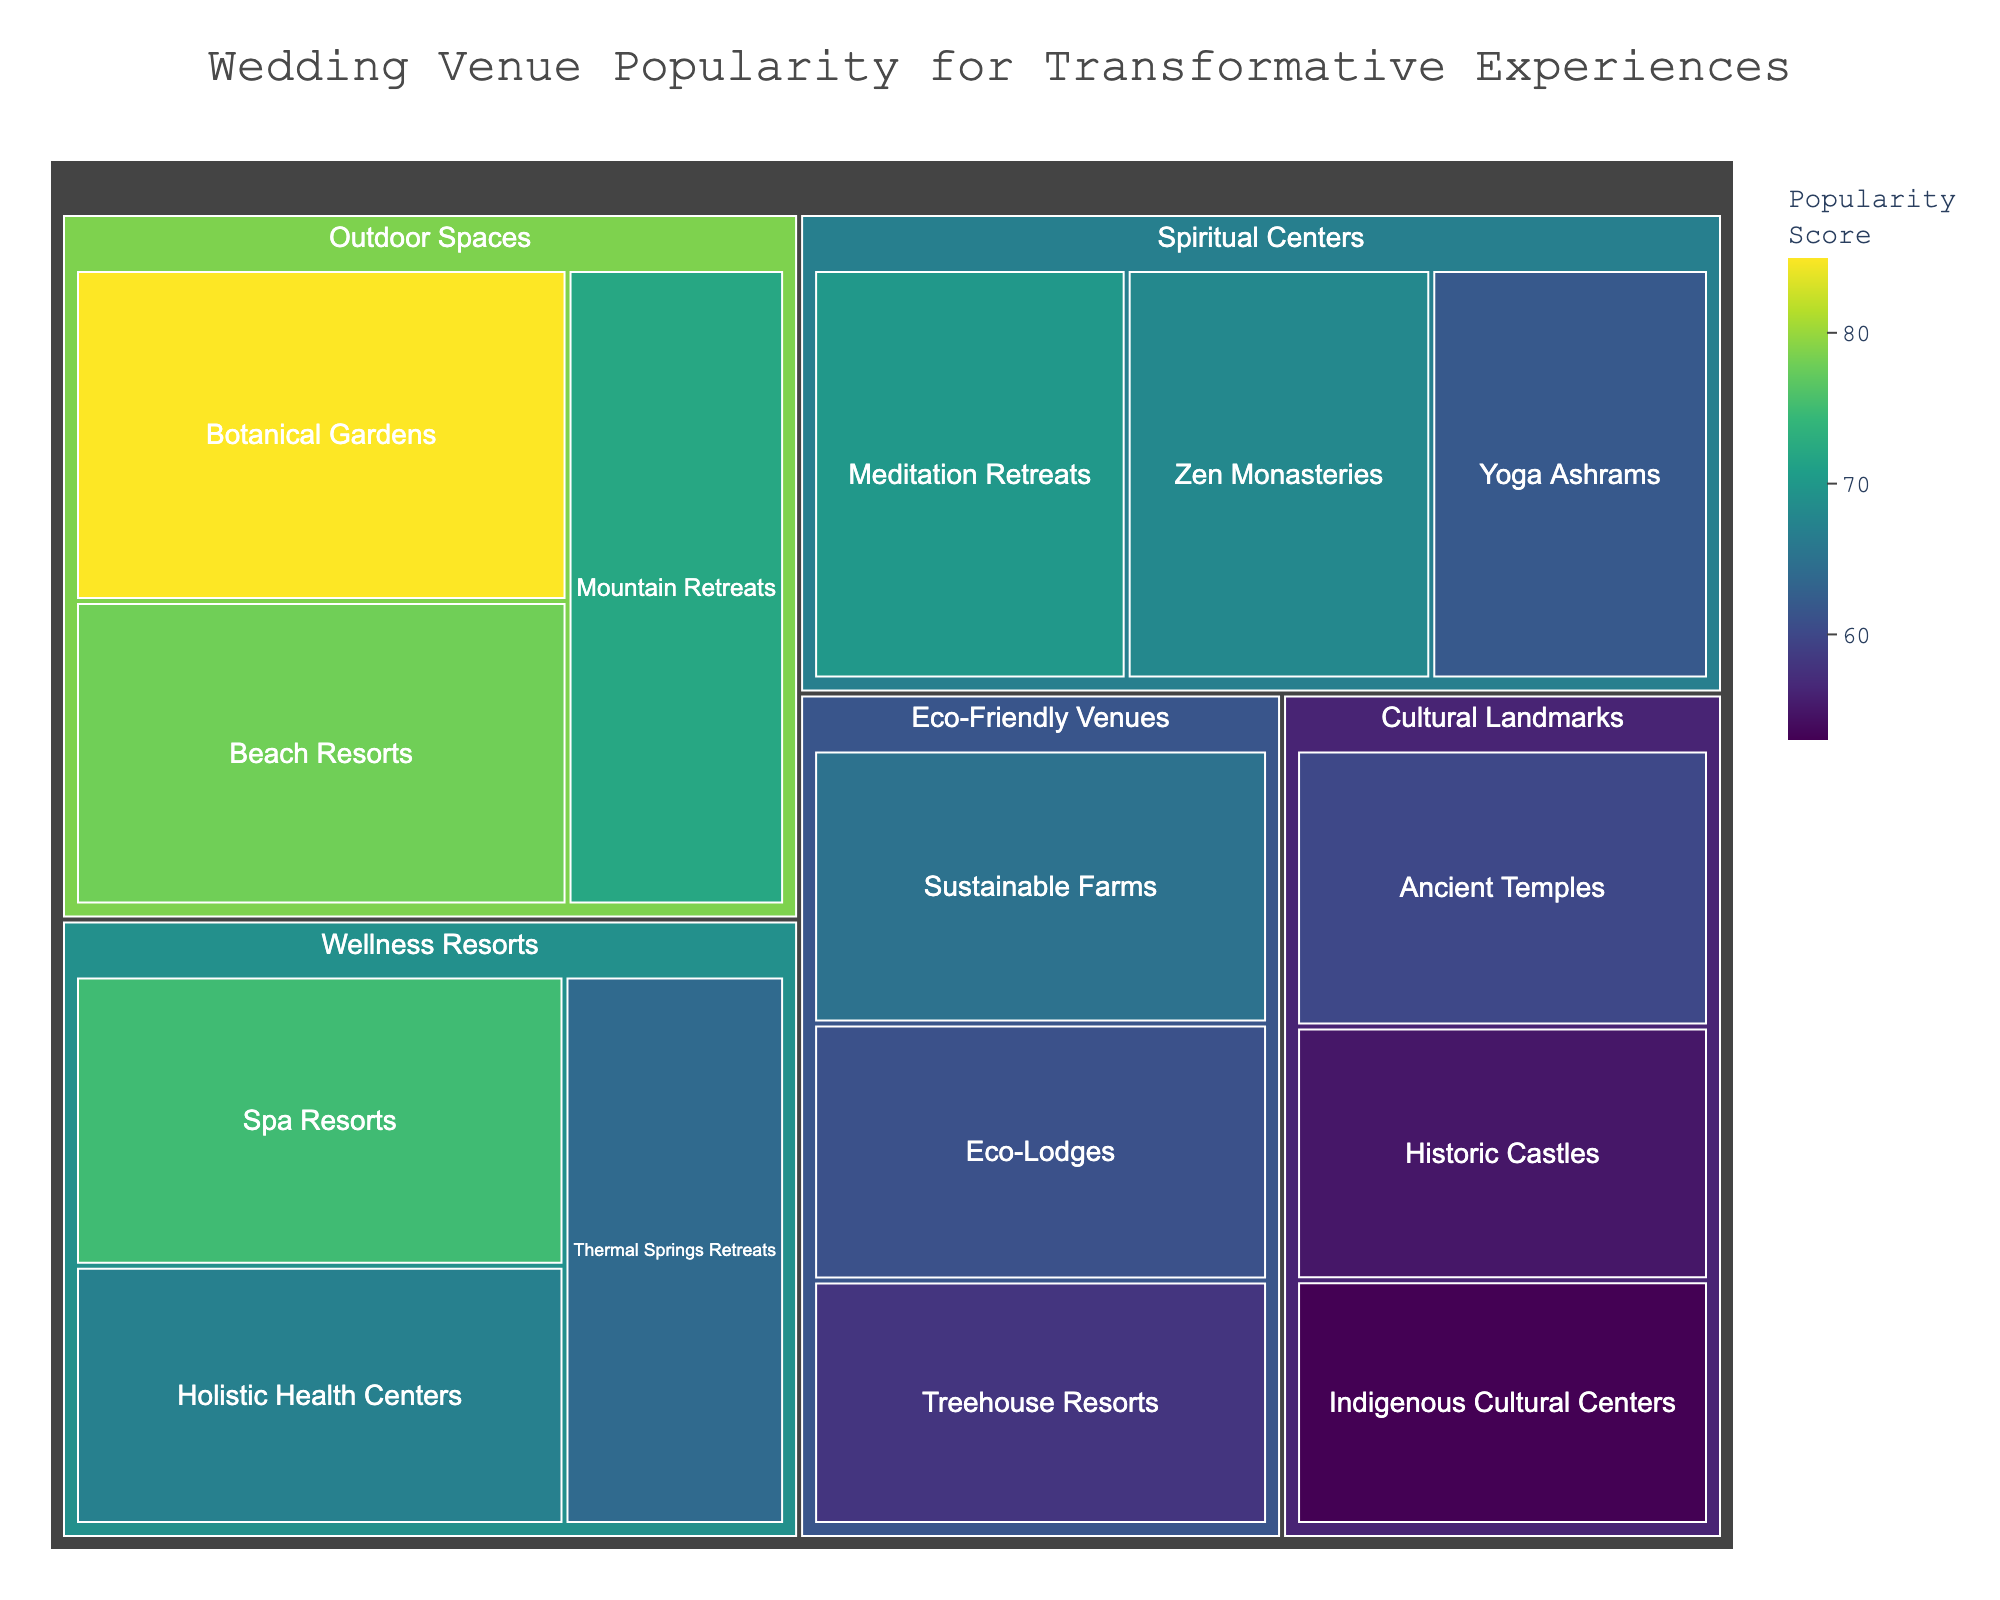What is the title of the treemap? The title is typically displayed prominently at the top of the figure. It provides a summary of what the treemap represents. In this case, the title of the treemap helps viewers understand the context of the data being displayed.
Answer: Wedding Venue Popularity for Transformative Experiences Which venue has the highest popularity score? The highest popularity score is visually represented by the largest and often the darkest tile in the treemap. Viewers can quickly identify the largest tile and read the associated label.
Answer: Botanical Gardens How many categories of wedding venues are displayed in the treemap? Categories can be identified by the different sections in the treemap. Each category groups several venues together and can be counted directly by looking at the organized subsections.
Answer: 5 Which category contains the venue with the lowest popularity score? To find the category with the lowest popularity score, identify the smallest or lightest tile that represents the lowest value and check the category it belongs to.
Answer: Cultural Landmarks What is the average popularity score of venues in the "Outdoor Spaces" category? To calculate the average, sum up the popularity scores of all venues in the "Outdoor Spaces" category and divide by the number of venues in that category. The Outdoor Spaces category includes Botanical Gardens (85), Beach Resorts (78), and Mountain Retreats (72). The sum is 85 + 78 + 72 = 235. Divided by 3 venues, the average score is 235 / 3.
Answer: 78.33 Which venue in the "Wellness Resorts" category has the second highest popularity score? To determine the second highest score within a category, first list all the scores within "Wellness Resorts": Spa Resorts (75), Holistic Health Centers (67), Thermal Springs Retreats (64). Next, order these scores from highest to lowest and identify the venue with the second highest score.
Answer: Holistic Health Centers Compare the total popularity scores of "Spiritual Centers" and "Eco-Friendly Venues". Which category has a higher total popularity score? Sum all popularity scores within each category. For Spiritual Centers: Zen Monasteries (68), Yoga Ashrams (62), Meditation Retreats (70), the total is 68 + 62 + 70 = 200. For Eco-Friendly Venues: Sustainable Farms (65), Treehouse Resorts (58), Eco-Lodges (61), the total is 65 + 58 + 61 = 184. Compare the totals to determine the category with the higher overall score.
Answer: Spiritual Centers What is the difference in popularity scores between the most and least popular venues? To find the difference, identify the highest and lowest popularity scores overall. The highest is Botanical Gardens (85), and the lowest is Indigenous Cultural Centers (53). Subtract the lowest score from the highest score: 85 - 53.
Answer: 32 Is there any category where all venues have a popularity score below 70? To answer this, examine each category's venues and check their popularity scores. If all scores in a category are below 70, then that category meets the criteria.
Answer: Eco-Friendly Venues 